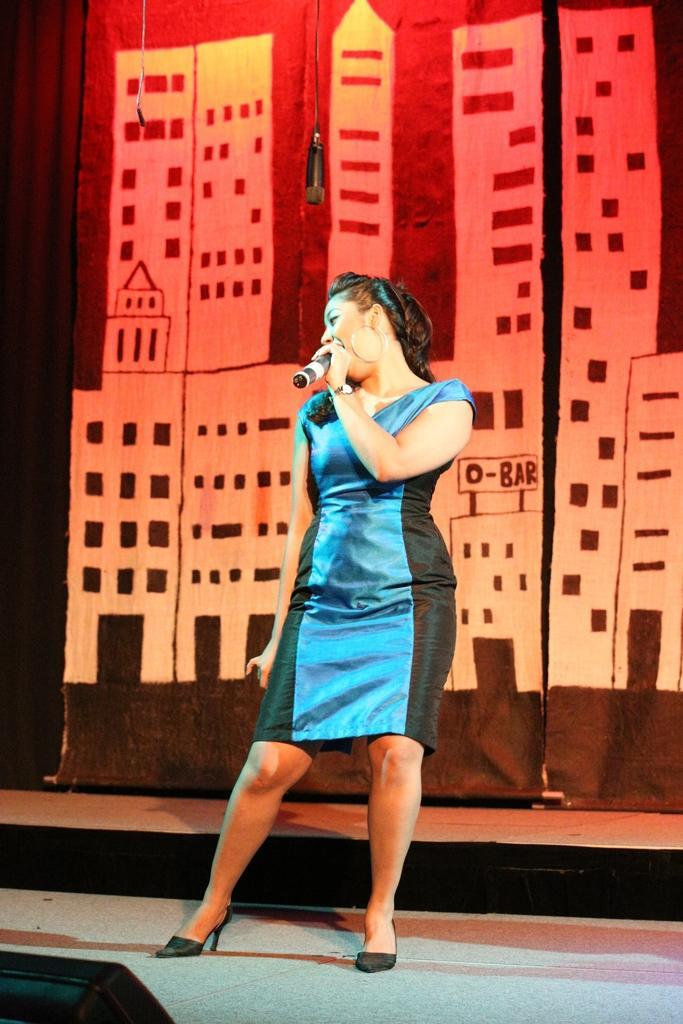In one or two sentences, can you explain what this image depicts? In this image I can see in the middle a woman is standing and holding the microphone, she is wearing blue color dress. In the background it looks like there are banners. 